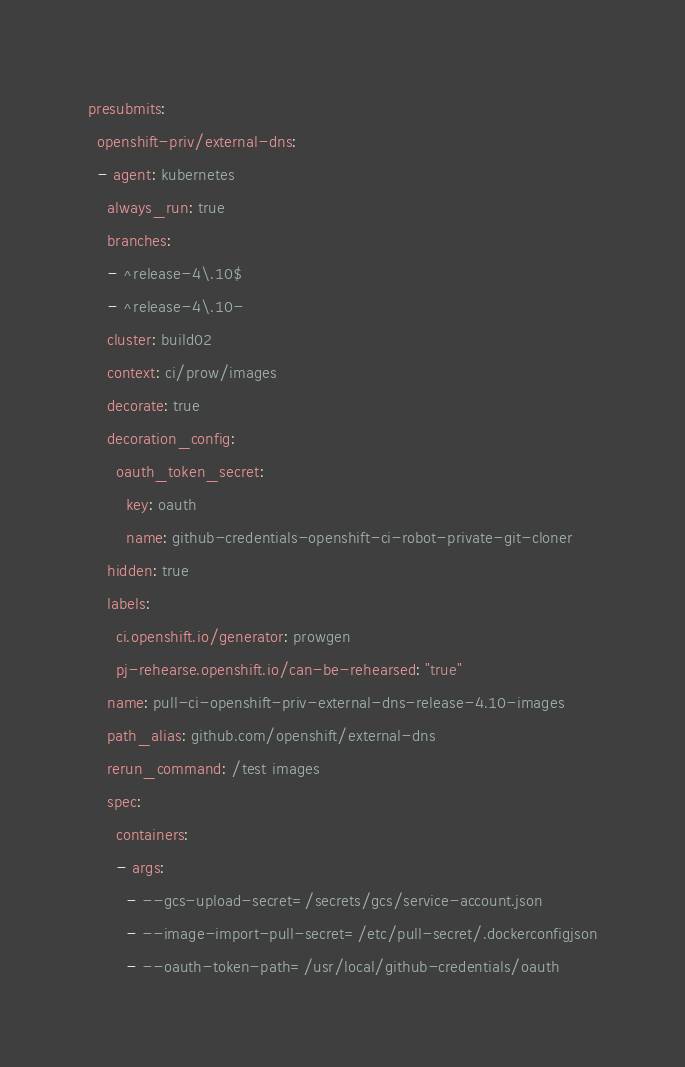<code> <loc_0><loc_0><loc_500><loc_500><_YAML_>presubmits:
  openshift-priv/external-dns:
  - agent: kubernetes
    always_run: true
    branches:
    - ^release-4\.10$
    - ^release-4\.10-
    cluster: build02
    context: ci/prow/images
    decorate: true
    decoration_config:
      oauth_token_secret:
        key: oauth
        name: github-credentials-openshift-ci-robot-private-git-cloner
    hidden: true
    labels:
      ci.openshift.io/generator: prowgen
      pj-rehearse.openshift.io/can-be-rehearsed: "true"
    name: pull-ci-openshift-priv-external-dns-release-4.10-images
    path_alias: github.com/openshift/external-dns
    rerun_command: /test images
    spec:
      containers:
      - args:
        - --gcs-upload-secret=/secrets/gcs/service-account.json
        - --image-import-pull-secret=/etc/pull-secret/.dockerconfigjson
        - --oauth-token-path=/usr/local/github-credentials/oauth</code> 